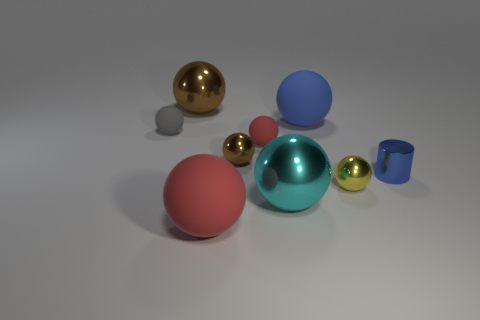Are there more red things behind the shiny cylinder than big red rubber objects?
Provide a short and direct response. No. What number of red things are the same size as the blue metal object?
Provide a succinct answer. 1. Is the size of the metal ball on the right side of the cyan metal sphere the same as the brown object that is in front of the big blue sphere?
Your answer should be very brief. Yes. There is a brown metal ball that is behind the big blue matte ball; what size is it?
Offer a very short reply. Large. How big is the brown metallic object that is in front of the brown thing that is to the left of the tiny brown ball?
Your response must be concise. Small. There is a blue object that is the same size as the yellow ball; what is it made of?
Provide a succinct answer. Metal. Are there any big red rubber objects behind the tiny yellow shiny object?
Offer a terse response. No. Are there the same number of tiny blue metal cylinders on the left side of the cyan sphere and blue spheres?
Your answer should be compact. No. What is the shape of the blue thing that is the same size as the gray matte sphere?
Offer a terse response. Cylinder. What is the material of the big blue thing?
Make the answer very short. Rubber. 